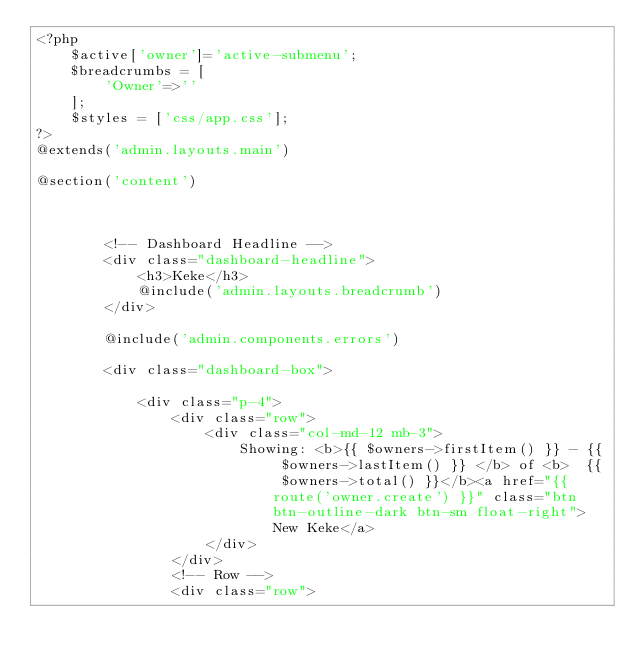Convert code to text. <code><loc_0><loc_0><loc_500><loc_500><_PHP_><?php
    $active['owner']='active-submenu';
    $breadcrumbs = [
        'Owner'=>''
    ];
    $styles = ['css/app.css'];
?>
@extends('admin.layouts.main')

@section('content')



        <!-- Dashboard Headline -->
        <div class="dashboard-headline">
            <h3>Keke</h3>
            @include('admin.layouts.breadcrumb')
        </div>

        @include('admin.components.errors')

        <div class="dashboard-box">

            <div class="p-4">
                <div class="row">
                    <div class="col-md-12 mb-3">
                        Showing: <b>{{ $owners->firstItem() }} - {{ $owners->lastItem() }} </b> of <b>  {{ $owners->total() }}</b><a href="{{ route('owner.create') }}" class="btn btn-outline-dark btn-sm float-right">New Keke</a>
                    </div>
                </div>
                <!-- Row -->
                <div class="row"></code> 